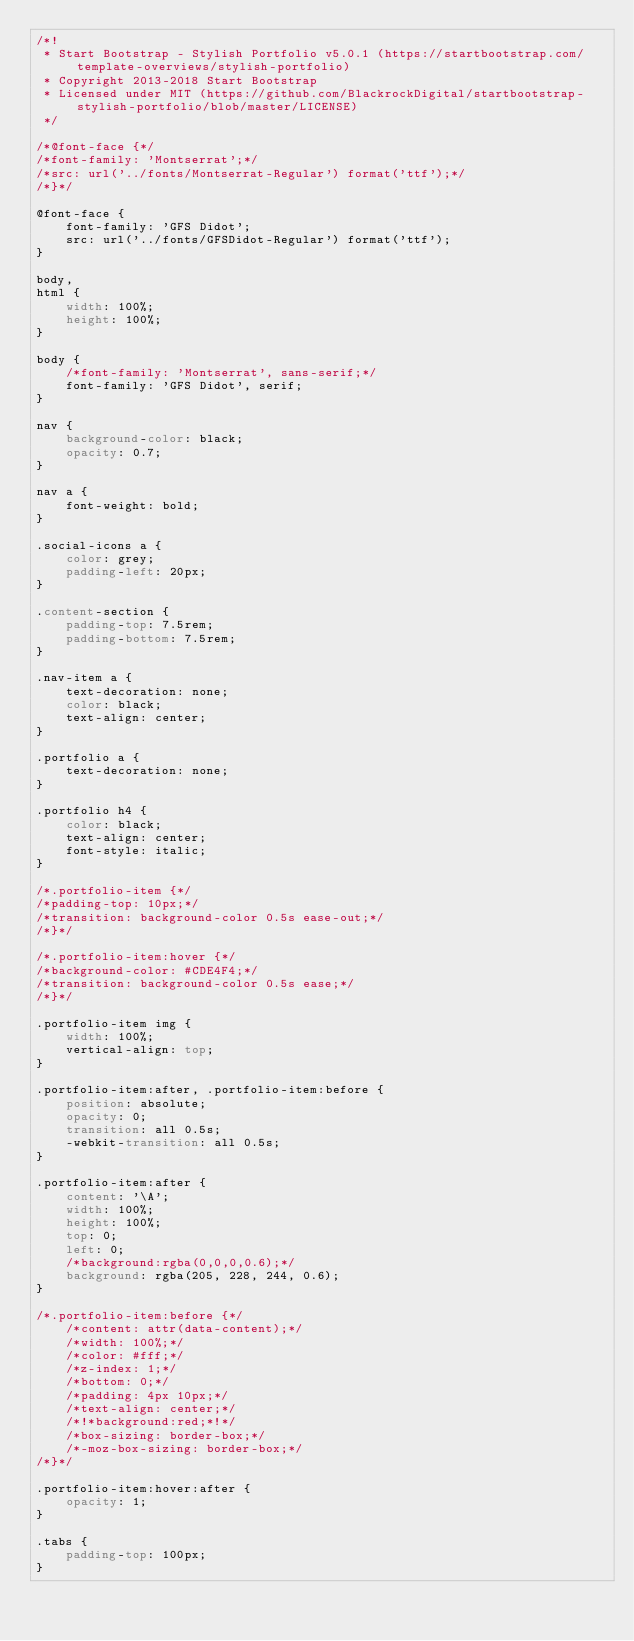<code> <loc_0><loc_0><loc_500><loc_500><_CSS_>/*!
 * Start Bootstrap - Stylish Portfolio v5.0.1 (https://startbootstrap.com/template-overviews/stylish-portfolio)
 * Copyright 2013-2018 Start Bootstrap
 * Licensed under MIT (https://github.com/BlackrockDigital/startbootstrap-stylish-portfolio/blob/master/LICENSE)
 */

/*@font-face {*/
/*font-family: 'Montserrat';*/
/*src: url('../fonts/Montserrat-Regular') format('ttf');*/
/*}*/

@font-face {
    font-family: 'GFS Didot';
    src: url('../fonts/GFSDidot-Regular') format('ttf');
}

body,
html {
    width: 100%;
    height: 100%;
}

body {
    /*font-family: 'Montserrat', sans-serif;*/
    font-family: 'GFS Didot', serif;
}

nav {
    background-color: black;
    opacity: 0.7;
}

nav a {
    font-weight: bold;
}

.social-icons a {
    color: grey;
    padding-left: 20px;
}

.content-section {
    padding-top: 7.5rem;
    padding-bottom: 7.5rem;
}

.nav-item a {
    text-decoration: none;
    color: black;
    text-align: center;
}

.portfolio a {
    text-decoration: none;
}

.portfolio h4 {
    color: black;
    text-align: center;
    font-style: italic;
}

/*.portfolio-item {*/
/*padding-top: 10px;*/
/*transition: background-color 0.5s ease-out;*/
/*}*/

/*.portfolio-item:hover {*/
/*background-color: #CDE4F4;*/
/*transition: background-color 0.5s ease;*/
/*}*/

.portfolio-item img {
    width: 100%;
    vertical-align: top;
}

.portfolio-item:after, .portfolio-item:before {
    position: absolute;
    opacity: 0;
    transition: all 0.5s;
    -webkit-transition: all 0.5s;
}

.portfolio-item:after {
    content: '\A';
    width: 100%;
    height: 100%;
    top: 0;
    left: 0;
    /*background:rgba(0,0,0,0.6);*/
    background: rgba(205, 228, 244, 0.6);
}

/*.portfolio-item:before {*/
    /*content: attr(data-content);*/
    /*width: 100%;*/
    /*color: #fff;*/
    /*z-index: 1;*/
    /*bottom: 0;*/
    /*padding: 4px 10px;*/
    /*text-align: center;*/
    /*!*background:red;*!*/
    /*box-sizing: border-box;*/
    /*-moz-box-sizing: border-box;*/
/*}*/

.portfolio-item:hover:after {
    opacity: 1;
}

.tabs {
    padding-top: 100px;
}
</code> 